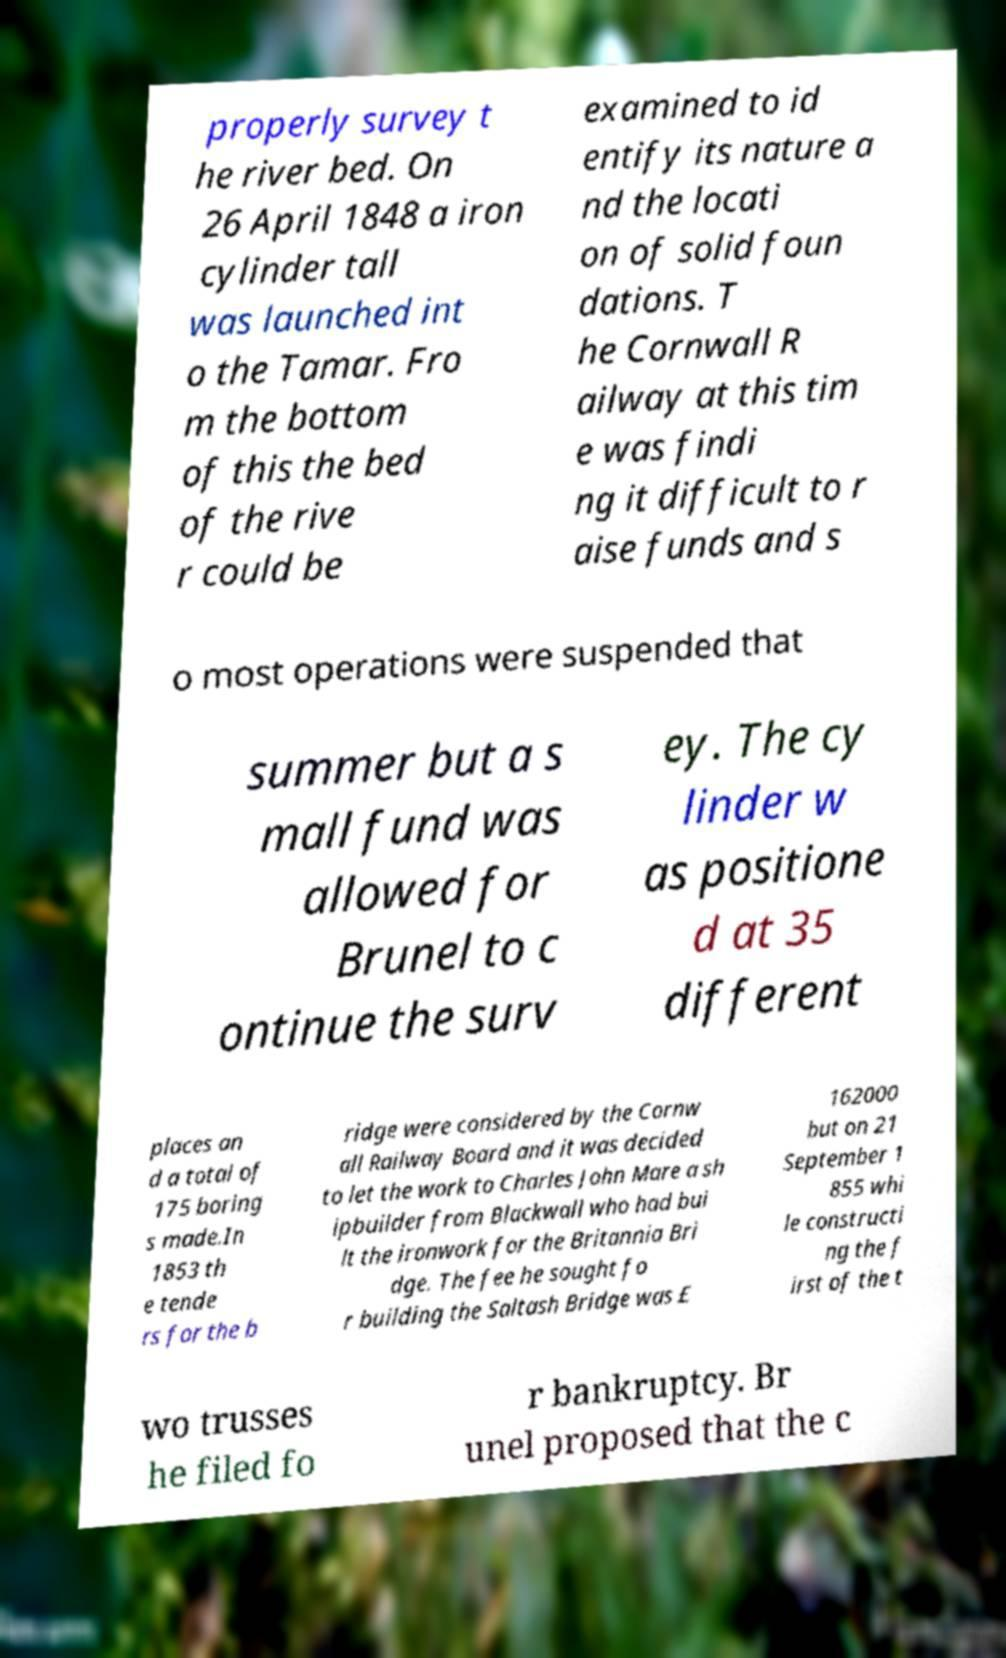Please read and relay the text visible in this image. What does it say? properly survey t he river bed. On 26 April 1848 a iron cylinder tall was launched int o the Tamar. Fro m the bottom of this the bed of the rive r could be examined to id entify its nature a nd the locati on of solid foun dations. T he Cornwall R ailway at this tim e was findi ng it difficult to r aise funds and s o most operations were suspended that summer but a s mall fund was allowed for Brunel to c ontinue the surv ey. The cy linder w as positione d at 35 different places an d a total of 175 boring s made.In 1853 th e tende rs for the b ridge were considered by the Cornw all Railway Board and it was decided to let the work to Charles John Mare a sh ipbuilder from Blackwall who had bui lt the ironwork for the Britannia Bri dge. The fee he sought fo r building the Saltash Bridge was £ 162000 but on 21 September 1 855 whi le constructi ng the f irst of the t wo trusses he filed fo r bankruptcy. Br unel proposed that the c 